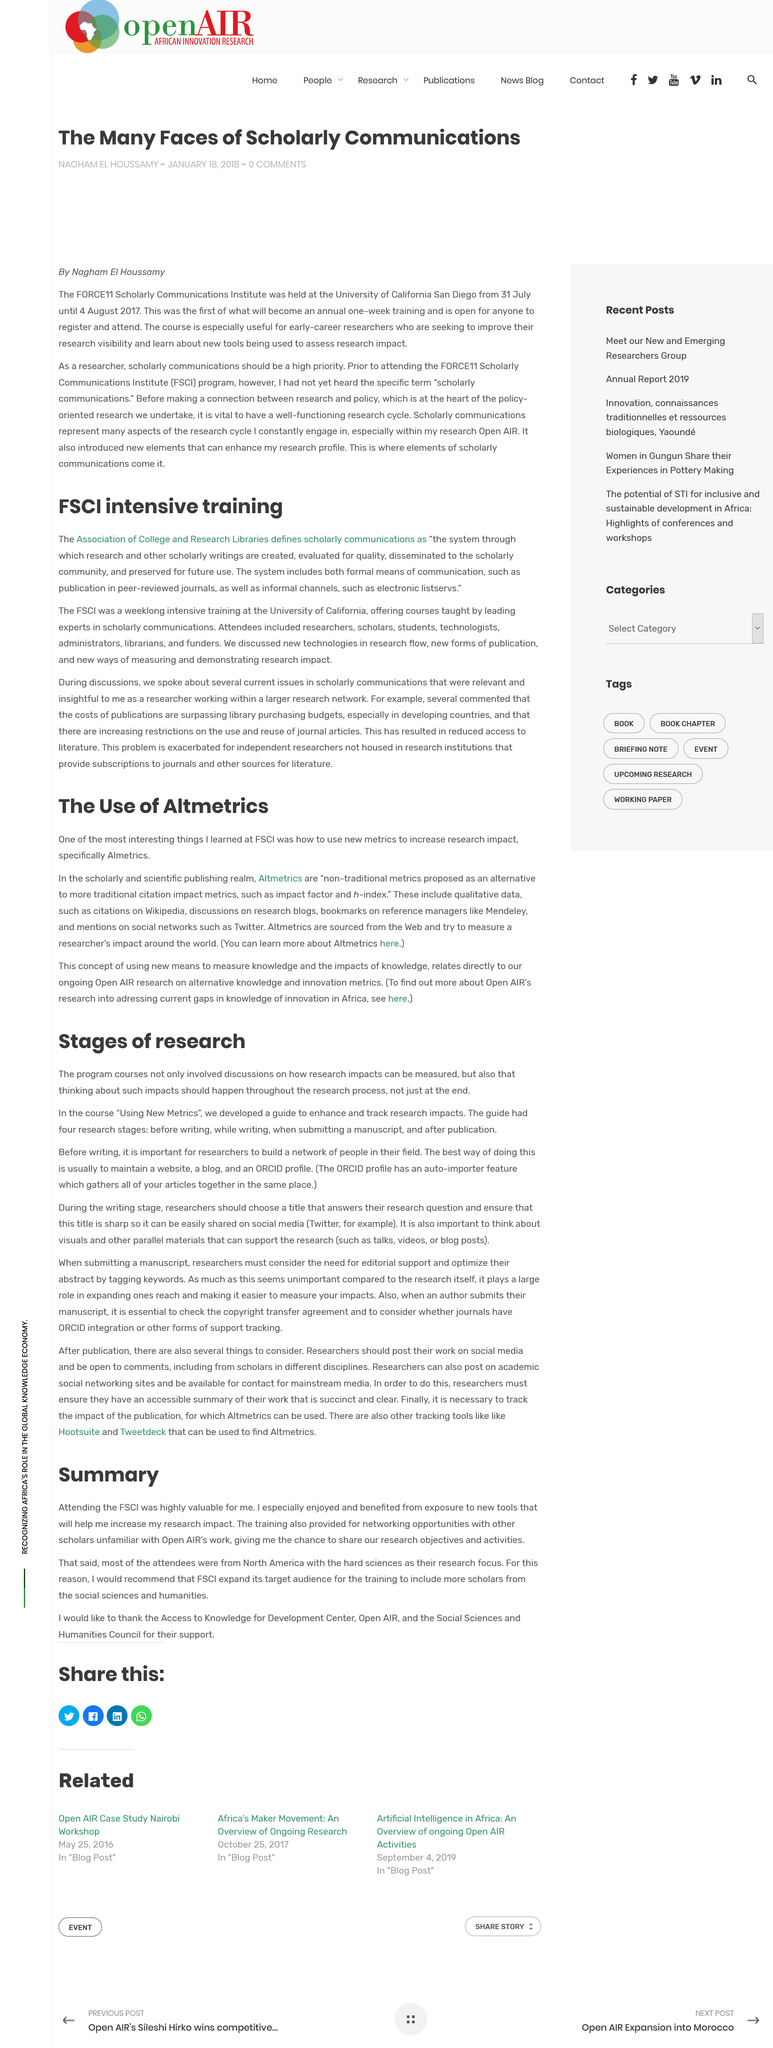Point out several critical features in this image. During the FCSI intensive training held at the University of California, various new technologies were discussed, including research flow, new forms of publication, and innovative methods for measuring and showcasing research impact. The majority of attendees were from North America. Publication in peer-reviewed journals is a formal means of communication within the scholarly communications framework. Researchers can build and maintain a network of people in their field by creating a website, maintaining a blog, and establishing an ORCID profile. The course "Using New Metrics" aids in enhancing and tracking research impacts for journal articles. 